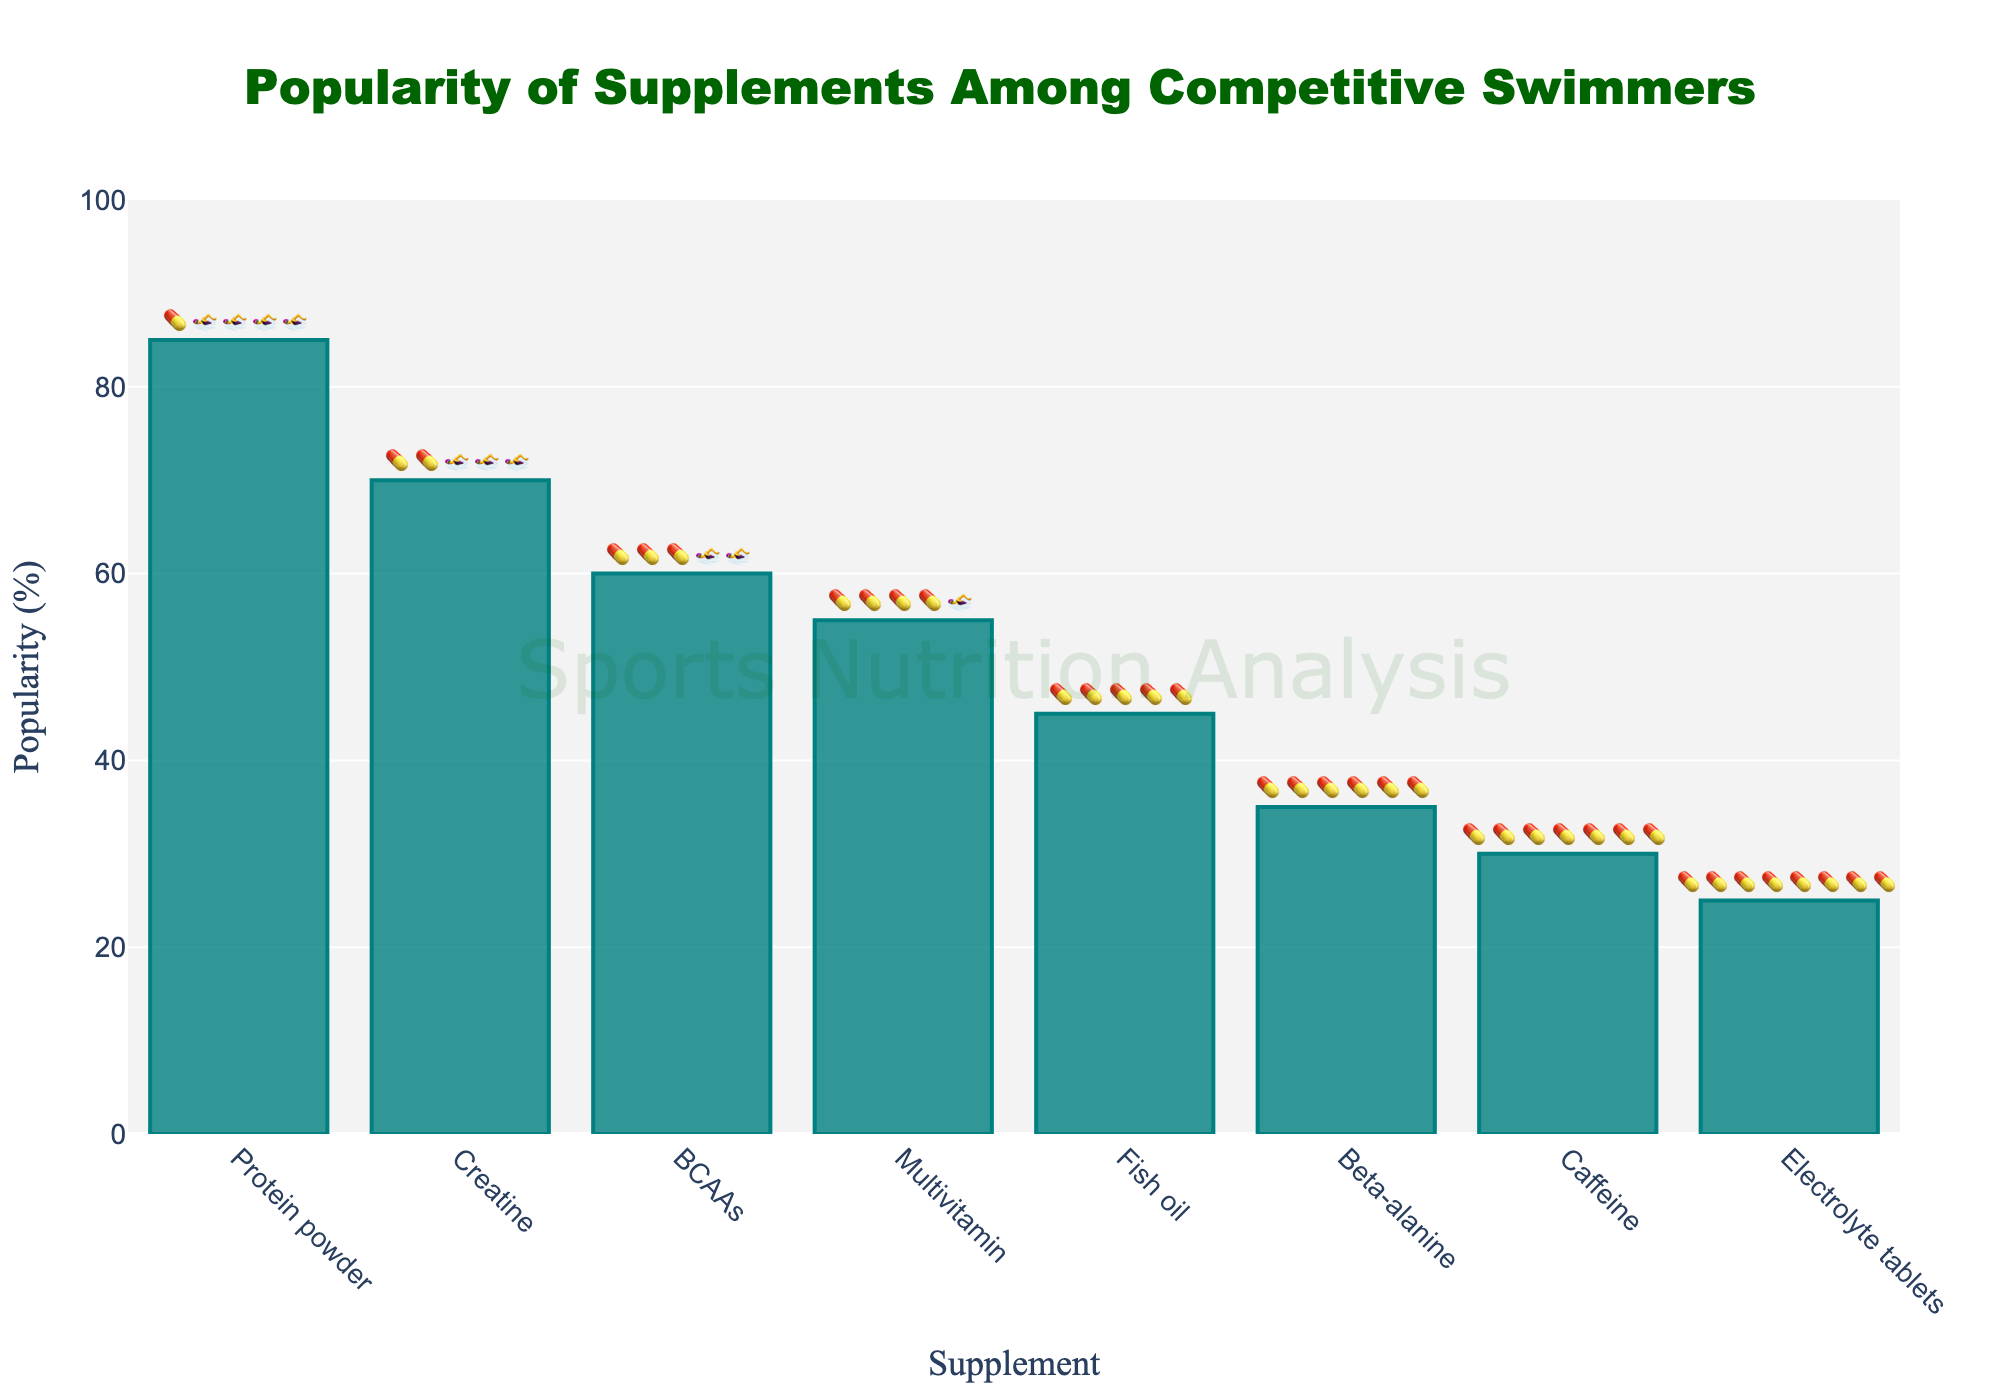How many supplements are listed in the chart? Count the number of distinct bars in the chart to get the total number of supplements listed.
Answer: 8 Which supplement has the highest popularity among competitive swimmers? Look for the highest bar in the chart, which represents the supplement with the highest popularity.
Answer: Protein powder What is the popularity percentage of Beta-alanine? Find the bar labeled "Beta-alanine" and read its height on the y-axis.
Answer: 35% What is the difference in popularity between Protein powder and Fish oil? The popularity of Protein powder is 85% and Fish oil is 45%. Subtract the popularity of Fish oil from Protein powder (85 - 45).
Answer: 40% Which is more popular among swimmers, Caffeine or Multivitamin? Compare the heights or percentages of the bars for Caffeine and Multivitamin. Caffeine is 30%, and Multivitamin is 55%.
Answer: Multivitamin What is the average popularity of the listed supplements? Sum the popularity percentages of all supplements (85 + 70 + 60 + 55 + 45 + 35 + 30 + 25) and divide by the number of supplements (8). The total is 405, so the average is 405 / 8.
Answer: 50.625% How many supplements have a popularity higher than 50%? Identify and count the bars with heights above 50%: Protein powder (85%), Creatine (70%), BCAAs (60%), and Multivitamin (55%).
Answer: 4 Is Electrolyte tablets more or less popular than Caffeine? Compare the heights or percentages of the bars for Caffeine and Electrolyte tablets. Electrolyte tablets is 25%, and Caffeine is 30%.
Answer: Less popular By what percentage is Multivitamin less popular than BCAAs? The popularity of BCAAs is 60%, and Multivitamin is 55%. Subtract Multivitamin from BCAAs (60 - 55).
Answer: 5% What do the swimmer emoji represent in the chart? Each swimmer emoji represents a supplement's popularity among competitive swimmers, symbolizing its targeted use in sports nutrition.
Answer: Supplement popularity 